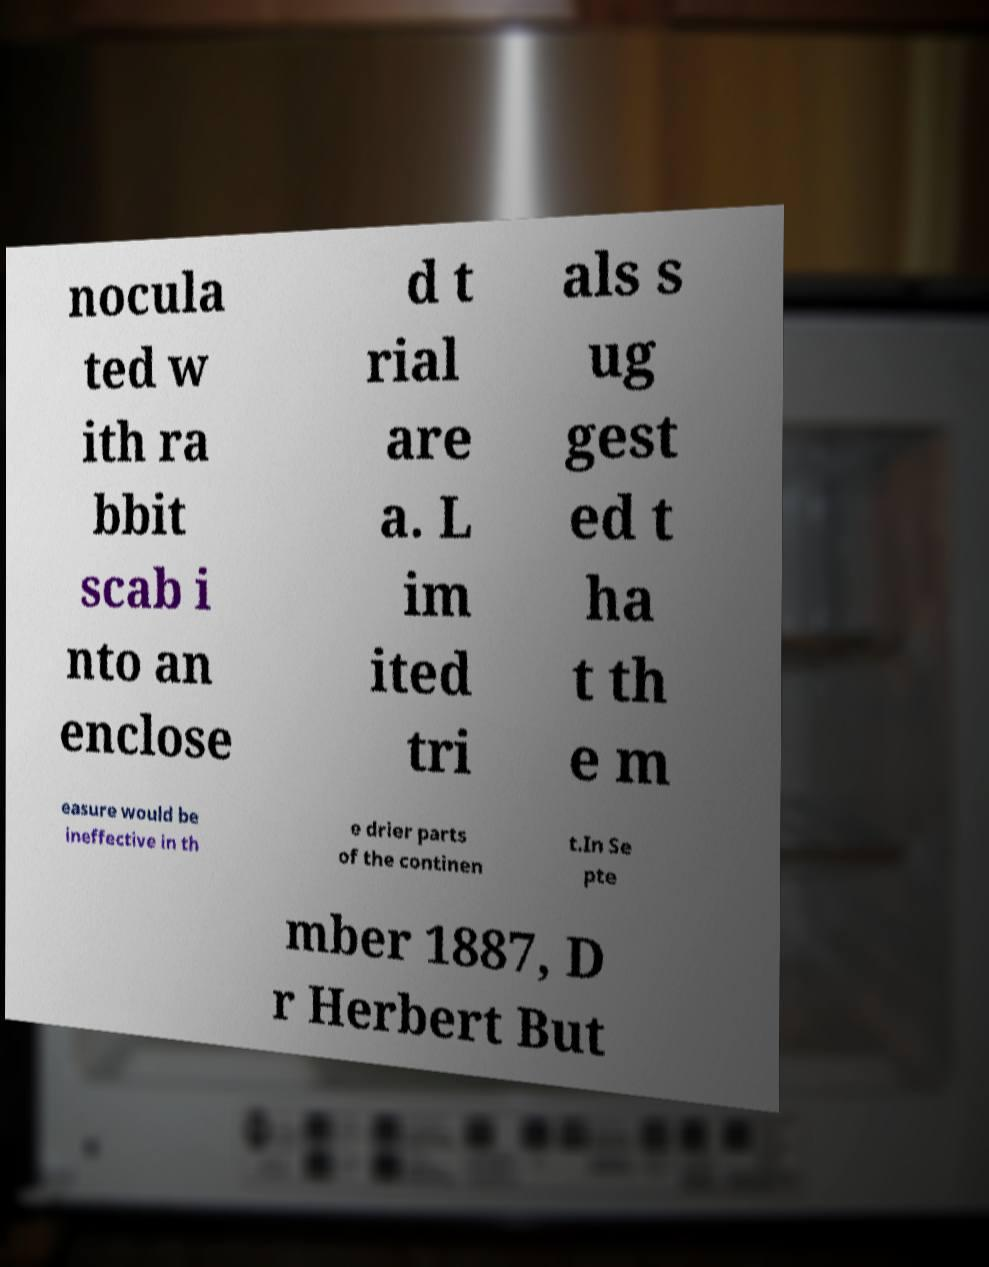Please read and relay the text visible in this image. What does it say? nocula ted w ith ra bbit scab i nto an enclose d t rial are a. L im ited tri als s ug gest ed t ha t th e m easure would be ineffective in th e drier parts of the continen t.In Se pte mber 1887, D r Herbert But 